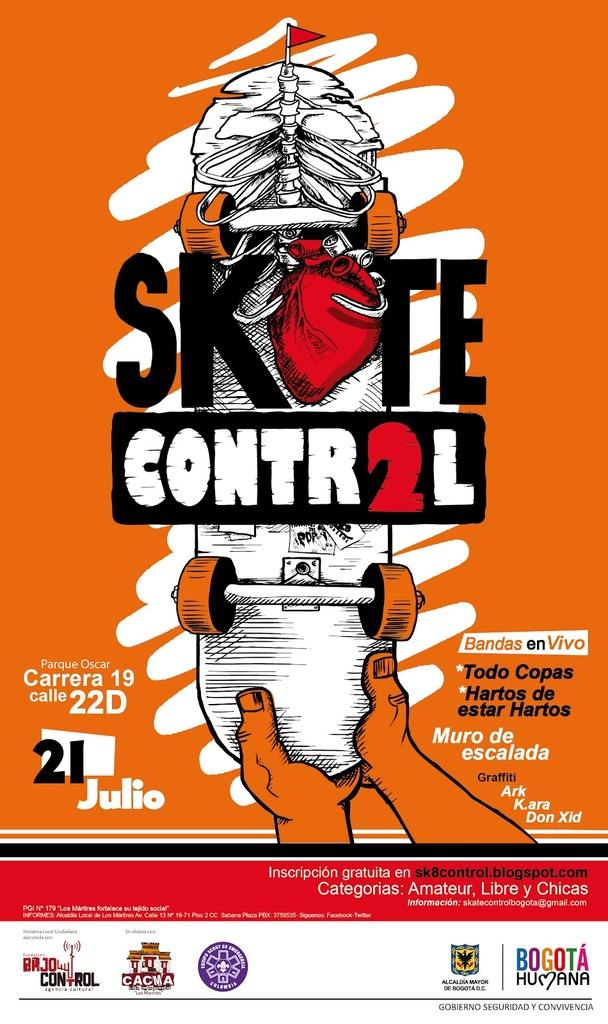<image>
Share a concise interpretation of the image provided. An advertisement on an orange background that says Skte Contr2l . 